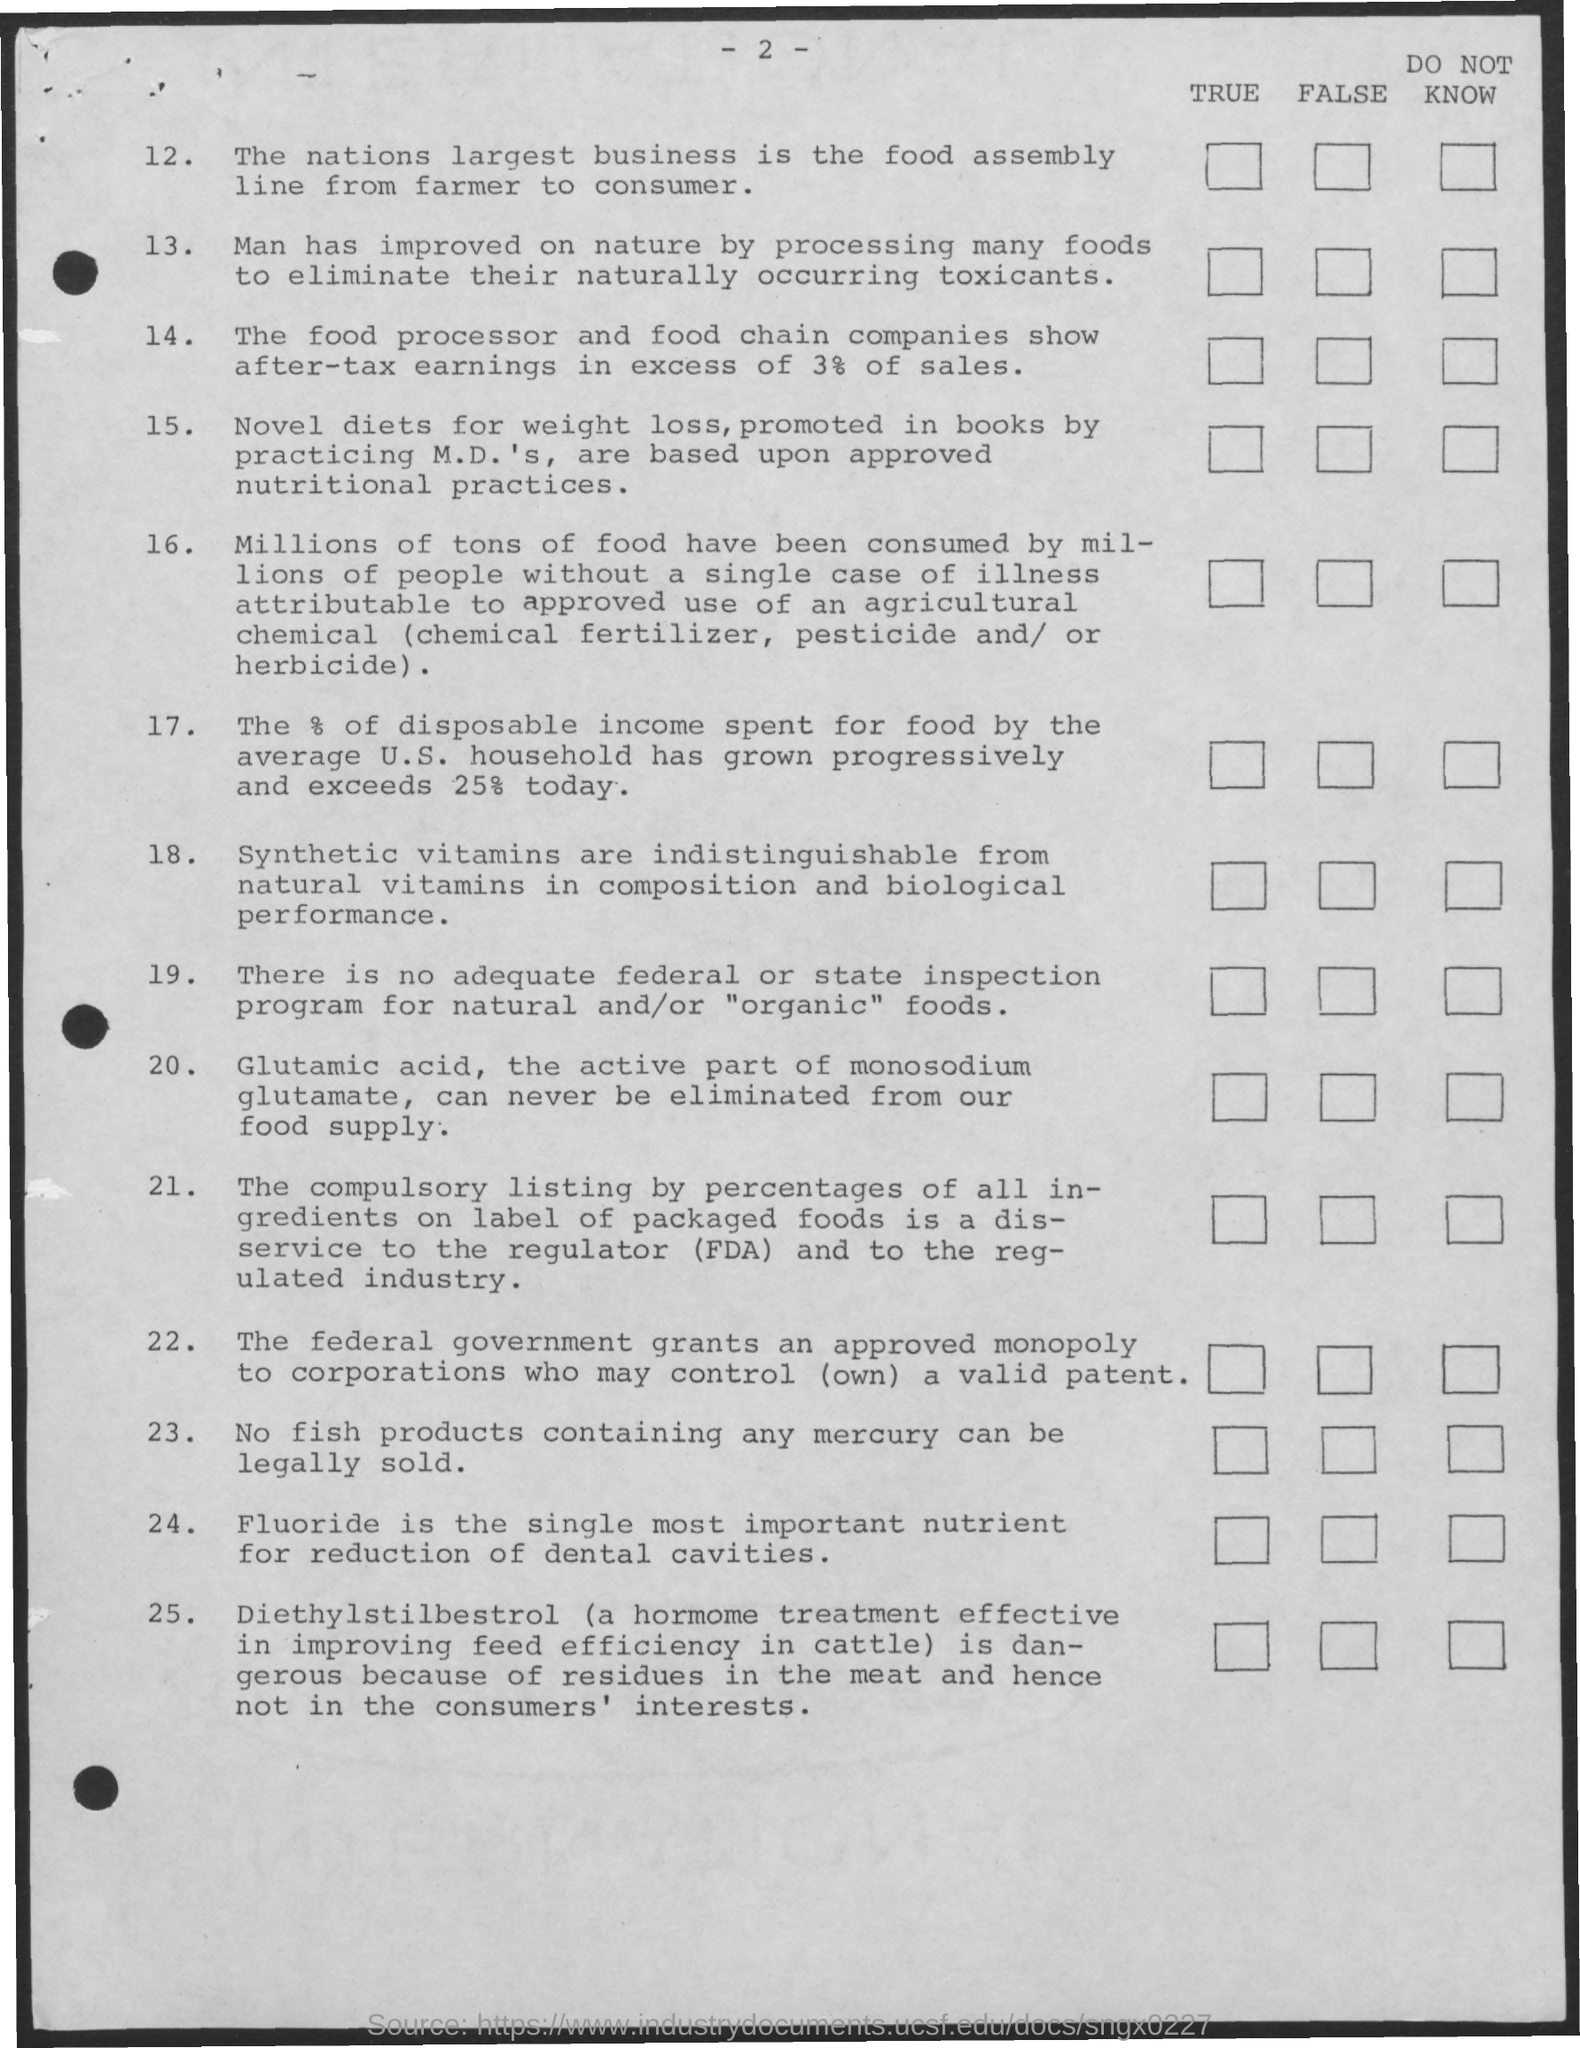What is the page number?
Offer a very short reply. 2. What is the serial number of the first statement?
Give a very brief answer. 12. What is the serial number of last statement?
Keep it short and to the point. 25. 